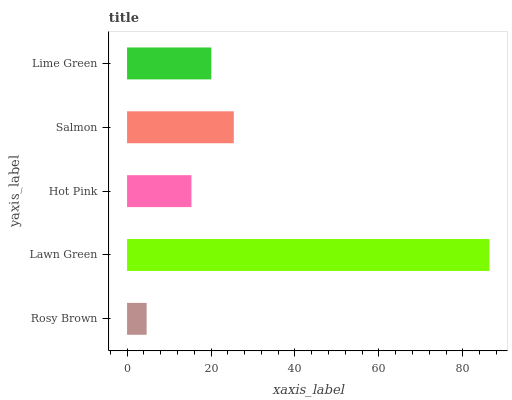Is Rosy Brown the minimum?
Answer yes or no. Yes. Is Lawn Green the maximum?
Answer yes or no. Yes. Is Hot Pink the minimum?
Answer yes or no. No. Is Hot Pink the maximum?
Answer yes or no. No. Is Lawn Green greater than Hot Pink?
Answer yes or no. Yes. Is Hot Pink less than Lawn Green?
Answer yes or no. Yes. Is Hot Pink greater than Lawn Green?
Answer yes or no. No. Is Lawn Green less than Hot Pink?
Answer yes or no. No. Is Lime Green the high median?
Answer yes or no. Yes. Is Lime Green the low median?
Answer yes or no. Yes. Is Lawn Green the high median?
Answer yes or no. No. Is Hot Pink the low median?
Answer yes or no. No. 